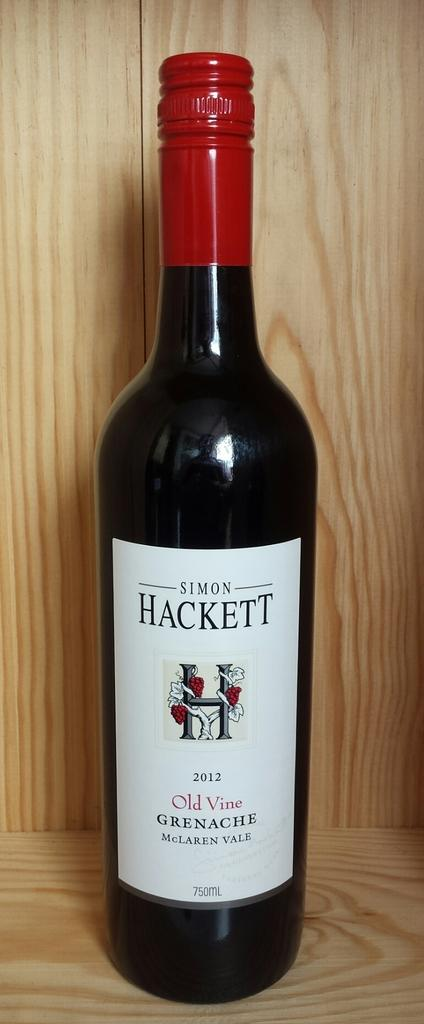<image>
Relay a brief, clear account of the picture shown. A bottle of Simon Hackett wine from 2012. 